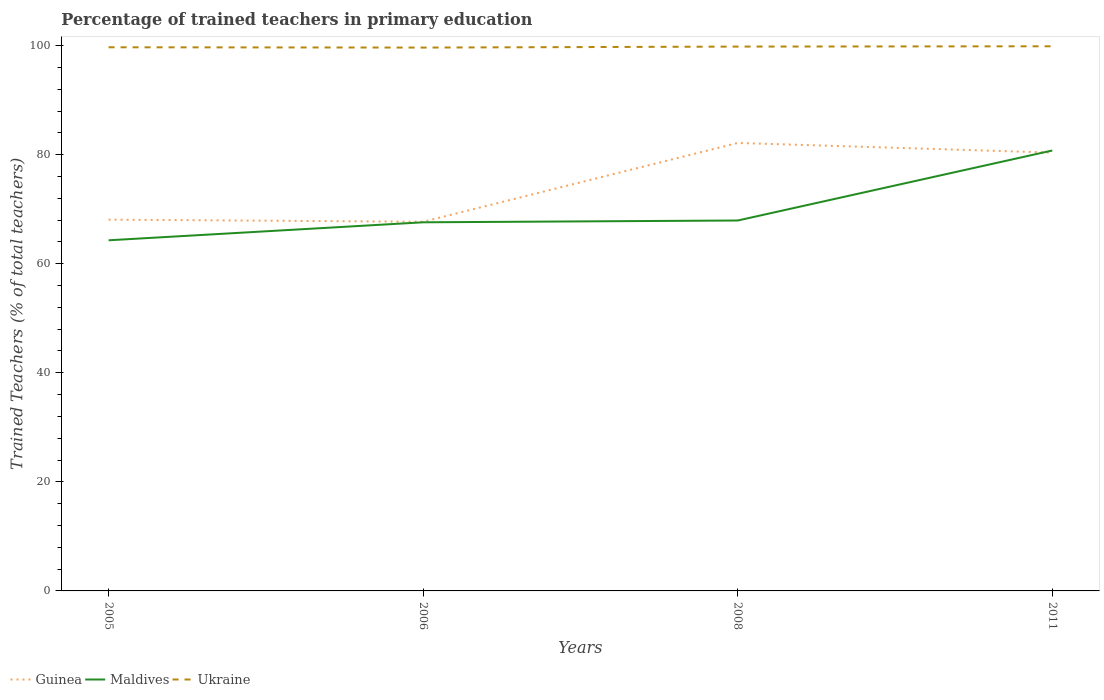How many different coloured lines are there?
Offer a very short reply. 3. Does the line corresponding to Guinea intersect with the line corresponding to Ukraine?
Keep it short and to the point. No. Is the number of lines equal to the number of legend labels?
Ensure brevity in your answer.  Yes. Across all years, what is the maximum percentage of trained teachers in Maldives?
Provide a succinct answer. 64.3. In which year was the percentage of trained teachers in Maldives maximum?
Provide a succinct answer. 2005. What is the total percentage of trained teachers in Maldives in the graph?
Give a very brief answer. -16.47. What is the difference between the highest and the second highest percentage of trained teachers in Guinea?
Your response must be concise. 14.45. What is the difference between the highest and the lowest percentage of trained teachers in Maldives?
Your answer should be very brief. 1. How many years are there in the graph?
Keep it short and to the point. 4. What is the difference between two consecutive major ticks on the Y-axis?
Provide a short and direct response. 20. Are the values on the major ticks of Y-axis written in scientific E-notation?
Keep it short and to the point. No. Does the graph contain any zero values?
Give a very brief answer. No. Does the graph contain grids?
Provide a short and direct response. No. How many legend labels are there?
Your answer should be very brief. 3. How are the legend labels stacked?
Provide a short and direct response. Horizontal. What is the title of the graph?
Your answer should be compact. Percentage of trained teachers in primary education. What is the label or title of the Y-axis?
Keep it short and to the point. Trained Teachers (% of total teachers). What is the Trained Teachers (% of total teachers) in Guinea in 2005?
Your response must be concise. 68.08. What is the Trained Teachers (% of total teachers) in Maldives in 2005?
Offer a terse response. 64.3. What is the Trained Teachers (% of total teachers) of Ukraine in 2005?
Your answer should be very brief. 99.69. What is the Trained Teachers (% of total teachers) of Guinea in 2006?
Keep it short and to the point. 67.7. What is the Trained Teachers (% of total teachers) of Maldives in 2006?
Provide a short and direct response. 67.6. What is the Trained Teachers (% of total teachers) of Ukraine in 2006?
Ensure brevity in your answer.  99.63. What is the Trained Teachers (% of total teachers) in Guinea in 2008?
Keep it short and to the point. 82.15. What is the Trained Teachers (% of total teachers) in Maldives in 2008?
Offer a terse response. 67.92. What is the Trained Teachers (% of total teachers) of Ukraine in 2008?
Your response must be concise. 99.82. What is the Trained Teachers (% of total teachers) in Guinea in 2011?
Offer a terse response. 80.38. What is the Trained Teachers (% of total teachers) in Maldives in 2011?
Your answer should be compact. 80.76. What is the Trained Teachers (% of total teachers) of Ukraine in 2011?
Make the answer very short. 99.87. Across all years, what is the maximum Trained Teachers (% of total teachers) of Guinea?
Keep it short and to the point. 82.15. Across all years, what is the maximum Trained Teachers (% of total teachers) of Maldives?
Make the answer very short. 80.76. Across all years, what is the maximum Trained Teachers (% of total teachers) in Ukraine?
Offer a very short reply. 99.87. Across all years, what is the minimum Trained Teachers (% of total teachers) in Guinea?
Keep it short and to the point. 67.7. Across all years, what is the minimum Trained Teachers (% of total teachers) in Maldives?
Offer a terse response. 64.3. Across all years, what is the minimum Trained Teachers (% of total teachers) in Ukraine?
Provide a short and direct response. 99.63. What is the total Trained Teachers (% of total teachers) in Guinea in the graph?
Ensure brevity in your answer.  298.3. What is the total Trained Teachers (% of total teachers) in Maldives in the graph?
Your answer should be compact. 280.58. What is the total Trained Teachers (% of total teachers) in Ukraine in the graph?
Offer a terse response. 399.01. What is the difference between the Trained Teachers (% of total teachers) of Guinea in 2005 and that in 2006?
Offer a very short reply. 0.39. What is the difference between the Trained Teachers (% of total teachers) of Maldives in 2005 and that in 2006?
Provide a succinct answer. -3.3. What is the difference between the Trained Teachers (% of total teachers) in Ukraine in 2005 and that in 2006?
Your answer should be very brief. 0.06. What is the difference between the Trained Teachers (% of total teachers) of Guinea in 2005 and that in 2008?
Your answer should be compact. -14.06. What is the difference between the Trained Teachers (% of total teachers) of Maldives in 2005 and that in 2008?
Give a very brief answer. -3.63. What is the difference between the Trained Teachers (% of total teachers) of Ukraine in 2005 and that in 2008?
Offer a very short reply. -0.12. What is the difference between the Trained Teachers (% of total teachers) of Guinea in 2005 and that in 2011?
Your response must be concise. -12.29. What is the difference between the Trained Teachers (% of total teachers) in Maldives in 2005 and that in 2011?
Your answer should be very brief. -16.47. What is the difference between the Trained Teachers (% of total teachers) of Ukraine in 2005 and that in 2011?
Keep it short and to the point. -0.18. What is the difference between the Trained Teachers (% of total teachers) in Guinea in 2006 and that in 2008?
Your answer should be very brief. -14.45. What is the difference between the Trained Teachers (% of total teachers) of Maldives in 2006 and that in 2008?
Keep it short and to the point. -0.33. What is the difference between the Trained Teachers (% of total teachers) in Ukraine in 2006 and that in 2008?
Offer a terse response. -0.18. What is the difference between the Trained Teachers (% of total teachers) in Guinea in 2006 and that in 2011?
Give a very brief answer. -12.68. What is the difference between the Trained Teachers (% of total teachers) of Maldives in 2006 and that in 2011?
Offer a very short reply. -13.17. What is the difference between the Trained Teachers (% of total teachers) of Ukraine in 2006 and that in 2011?
Your response must be concise. -0.24. What is the difference between the Trained Teachers (% of total teachers) of Guinea in 2008 and that in 2011?
Keep it short and to the point. 1.77. What is the difference between the Trained Teachers (% of total teachers) of Maldives in 2008 and that in 2011?
Your response must be concise. -12.84. What is the difference between the Trained Teachers (% of total teachers) in Ukraine in 2008 and that in 2011?
Give a very brief answer. -0.06. What is the difference between the Trained Teachers (% of total teachers) of Guinea in 2005 and the Trained Teachers (% of total teachers) of Maldives in 2006?
Offer a very short reply. 0.49. What is the difference between the Trained Teachers (% of total teachers) of Guinea in 2005 and the Trained Teachers (% of total teachers) of Ukraine in 2006?
Provide a short and direct response. -31.55. What is the difference between the Trained Teachers (% of total teachers) of Maldives in 2005 and the Trained Teachers (% of total teachers) of Ukraine in 2006?
Offer a terse response. -35.34. What is the difference between the Trained Teachers (% of total teachers) of Guinea in 2005 and the Trained Teachers (% of total teachers) of Maldives in 2008?
Offer a very short reply. 0.16. What is the difference between the Trained Teachers (% of total teachers) of Guinea in 2005 and the Trained Teachers (% of total teachers) of Ukraine in 2008?
Your answer should be very brief. -31.73. What is the difference between the Trained Teachers (% of total teachers) in Maldives in 2005 and the Trained Teachers (% of total teachers) in Ukraine in 2008?
Your response must be concise. -35.52. What is the difference between the Trained Teachers (% of total teachers) of Guinea in 2005 and the Trained Teachers (% of total teachers) of Maldives in 2011?
Ensure brevity in your answer.  -12.68. What is the difference between the Trained Teachers (% of total teachers) in Guinea in 2005 and the Trained Teachers (% of total teachers) in Ukraine in 2011?
Your answer should be compact. -31.79. What is the difference between the Trained Teachers (% of total teachers) in Maldives in 2005 and the Trained Teachers (% of total teachers) in Ukraine in 2011?
Offer a terse response. -35.58. What is the difference between the Trained Teachers (% of total teachers) in Guinea in 2006 and the Trained Teachers (% of total teachers) in Maldives in 2008?
Make the answer very short. -0.23. What is the difference between the Trained Teachers (% of total teachers) in Guinea in 2006 and the Trained Teachers (% of total teachers) in Ukraine in 2008?
Provide a short and direct response. -32.12. What is the difference between the Trained Teachers (% of total teachers) of Maldives in 2006 and the Trained Teachers (% of total teachers) of Ukraine in 2008?
Keep it short and to the point. -32.22. What is the difference between the Trained Teachers (% of total teachers) in Guinea in 2006 and the Trained Teachers (% of total teachers) in Maldives in 2011?
Make the answer very short. -13.07. What is the difference between the Trained Teachers (% of total teachers) in Guinea in 2006 and the Trained Teachers (% of total teachers) in Ukraine in 2011?
Your response must be concise. -32.18. What is the difference between the Trained Teachers (% of total teachers) of Maldives in 2006 and the Trained Teachers (% of total teachers) of Ukraine in 2011?
Provide a short and direct response. -32.28. What is the difference between the Trained Teachers (% of total teachers) of Guinea in 2008 and the Trained Teachers (% of total teachers) of Maldives in 2011?
Give a very brief answer. 1.38. What is the difference between the Trained Teachers (% of total teachers) in Guinea in 2008 and the Trained Teachers (% of total teachers) in Ukraine in 2011?
Your answer should be very brief. -17.73. What is the difference between the Trained Teachers (% of total teachers) of Maldives in 2008 and the Trained Teachers (% of total teachers) of Ukraine in 2011?
Provide a short and direct response. -31.95. What is the average Trained Teachers (% of total teachers) of Guinea per year?
Provide a succinct answer. 74.57. What is the average Trained Teachers (% of total teachers) in Maldives per year?
Give a very brief answer. 70.14. What is the average Trained Teachers (% of total teachers) of Ukraine per year?
Keep it short and to the point. 99.75. In the year 2005, what is the difference between the Trained Teachers (% of total teachers) of Guinea and Trained Teachers (% of total teachers) of Maldives?
Make the answer very short. 3.79. In the year 2005, what is the difference between the Trained Teachers (% of total teachers) in Guinea and Trained Teachers (% of total teachers) in Ukraine?
Make the answer very short. -31.61. In the year 2005, what is the difference between the Trained Teachers (% of total teachers) in Maldives and Trained Teachers (% of total teachers) in Ukraine?
Keep it short and to the point. -35.39. In the year 2006, what is the difference between the Trained Teachers (% of total teachers) of Guinea and Trained Teachers (% of total teachers) of Maldives?
Your response must be concise. 0.1. In the year 2006, what is the difference between the Trained Teachers (% of total teachers) in Guinea and Trained Teachers (% of total teachers) in Ukraine?
Keep it short and to the point. -31.94. In the year 2006, what is the difference between the Trained Teachers (% of total teachers) in Maldives and Trained Teachers (% of total teachers) in Ukraine?
Ensure brevity in your answer.  -32.04. In the year 2008, what is the difference between the Trained Teachers (% of total teachers) in Guinea and Trained Teachers (% of total teachers) in Maldives?
Your answer should be compact. 14.22. In the year 2008, what is the difference between the Trained Teachers (% of total teachers) in Guinea and Trained Teachers (% of total teachers) in Ukraine?
Your answer should be very brief. -17.67. In the year 2008, what is the difference between the Trained Teachers (% of total teachers) in Maldives and Trained Teachers (% of total teachers) in Ukraine?
Make the answer very short. -31.89. In the year 2011, what is the difference between the Trained Teachers (% of total teachers) in Guinea and Trained Teachers (% of total teachers) in Maldives?
Offer a terse response. -0.39. In the year 2011, what is the difference between the Trained Teachers (% of total teachers) of Guinea and Trained Teachers (% of total teachers) of Ukraine?
Ensure brevity in your answer.  -19.5. In the year 2011, what is the difference between the Trained Teachers (% of total teachers) of Maldives and Trained Teachers (% of total teachers) of Ukraine?
Provide a succinct answer. -19.11. What is the ratio of the Trained Teachers (% of total teachers) in Maldives in 2005 to that in 2006?
Make the answer very short. 0.95. What is the ratio of the Trained Teachers (% of total teachers) of Ukraine in 2005 to that in 2006?
Provide a short and direct response. 1. What is the ratio of the Trained Teachers (% of total teachers) of Guinea in 2005 to that in 2008?
Keep it short and to the point. 0.83. What is the ratio of the Trained Teachers (% of total teachers) in Maldives in 2005 to that in 2008?
Your answer should be very brief. 0.95. What is the ratio of the Trained Teachers (% of total teachers) of Ukraine in 2005 to that in 2008?
Offer a terse response. 1. What is the ratio of the Trained Teachers (% of total teachers) of Guinea in 2005 to that in 2011?
Your answer should be very brief. 0.85. What is the ratio of the Trained Teachers (% of total teachers) in Maldives in 2005 to that in 2011?
Ensure brevity in your answer.  0.8. What is the ratio of the Trained Teachers (% of total teachers) of Guinea in 2006 to that in 2008?
Your response must be concise. 0.82. What is the ratio of the Trained Teachers (% of total teachers) in Ukraine in 2006 to that in 2008?
Offer a terse response. 1. What is the ratio of the Trained Teachers (% of total teachers) of Guinea in 2006 to that in 2011?
Offer a very short reply. 0.84. What is the ratio of the Trained Teachers (% of total teachers) in Maldives in 2006 to that in 2011?
Make the answer very short. 0.84. What is the ratio of the Trained Teachers (% of total teachers) of Ukraine in 2006 to that in 2011?
Offer a terse response. 1. What is the ratio of the Trained Teachers (% of total teachers) in Guinea in 2008 to that in 2011?
Provide a succinct answer. 1.02. What is the ratio of the Trained Teachers (% of total teachers) in Maldives in 2008 to that in 2011?
Your response must be concise. 0.84. What is the difference between the highest and the second highest Trained Teachers (% of total teachers) in Guinea?
Provide a short and direct response. 1.77. What is the difference between the highest and the second highest Trained Teachers (% of total teachers) in Maldives?
Your response must be concise. 12.84. What is the difference between the highest and the second highest Trained Teachers (% of total teachers) of Ukraine?
Your response must be concise. 0.06. What is the difference between the highest and the lowest Trained Teachers (% of total teachers) of Guinea?
Your response must be concise. 14.45. What is the difference between the highest and the lowest Trained Teachers (% of total teachers) in Maldives?
Provide a succinct answer. 16.47. What is the difference between the highest and the lowest Trained Teachers (% of total teachers) in Ukraine?
Ensure brevity in your answer.  0.24. 